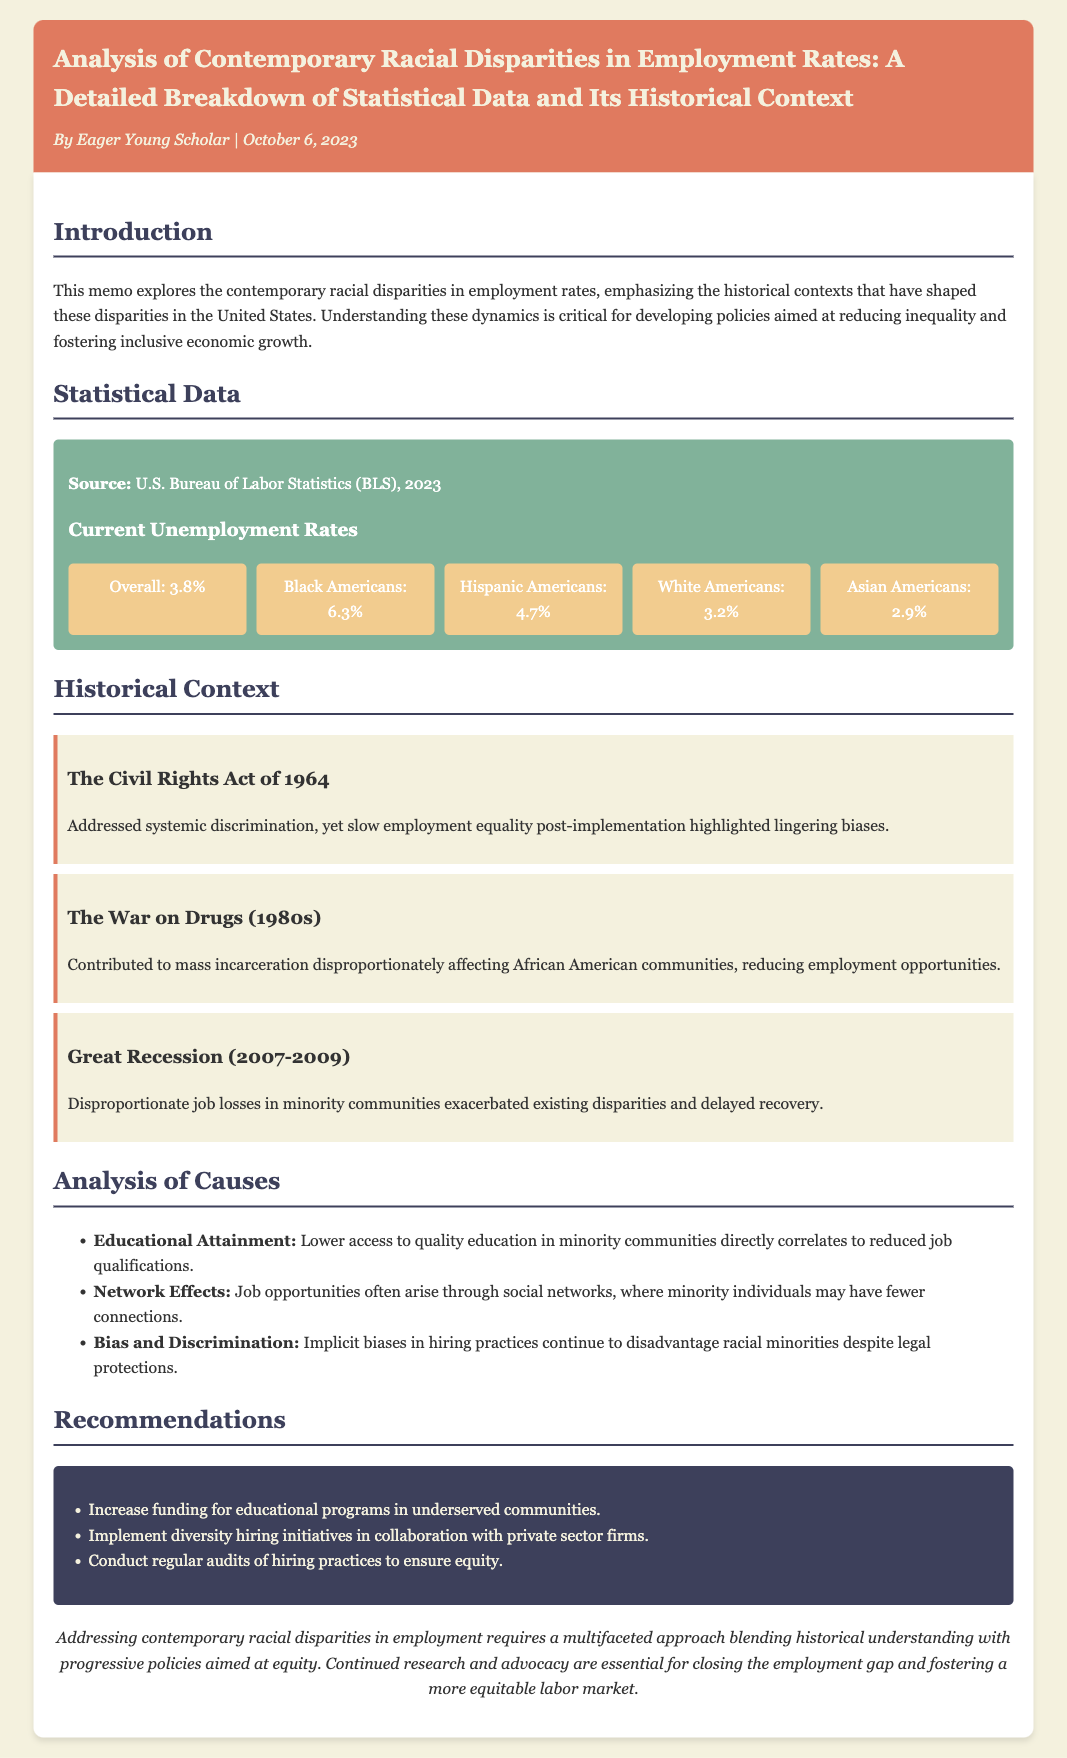What is the overall unemployment rate mentioned? The overall unemployment rate is stated in the document as part of the statistical data section.
Answer: 3.8% What is the unemployment rate for Black Americans? The unemployment rate for Black Americans is specifically mentioned in the current unemployment rates section.
Answer: 6.3% Which historical event highlighted slow employment equality post-implementation? The document discusses several historical events, one of which is identified as highlighting lingering biases affecting employment equality.
Answer: The Civil Rights Act of 1964 What are the recommended actions for addressing educational disparities? The recommendations section lists specific actions to improve conditions for minority communities.
Answer: Increase funding for educational programs in underserved communities What impact did the Great Recession have on minority communities? The document outlines effects of the Great Recession in relation to employment rates and minority communities.
Answer: Disproportionate job losses What cause is associated with reduced job qualifications in minority communities? The analysis of causes section provides insight into factors affecting employment in minority communities.
Answer: Educational Attainment What type of document is this? The title and overall structure of the document indicate its purpose and type.
Answer: Memo What is the publication date of the memo? The publication date is noted in the memo header, which includes the author and date.
Answer: October 6, 2023 